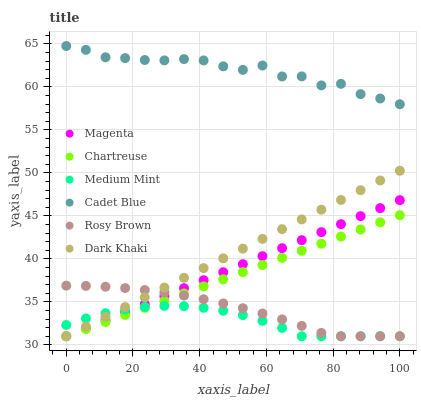Does Medium Mint have the minimum area under the curve?
Answer yes or no. Yes. Does Cadet Blue have the maximum area under the curve?
Answer yes or no. Yes. Does Rosy Brown have the minimum area under the curve?
Answer yes or no. No. Does Rosy Brown have the maximum area under the curve?
Answer yes or no. No. Is Chartreuse the smoothest?
Answer yes or no. Yes. Is Cadet Blue the roughest?
Answer yes or no. Yes. Is Rosy Brown the smoothest?
Answer yes or no. No. Is Rosy Brown the roughest?
Answer yes or no. No. Does Medium Mint have the lowest value?
Answer yes or no. Yes. Does Cadet Blue have the lowest value?
Answer yes or no. No. Does Cadet Blue have the highest value?
Answer yes or no. Yes. Does Rosy Brown have the highest value?
Answer yes or no. No. Is Rosy Brown less than Cadet Blue?
Answer yes or no. Yes. Is Cadet Blue greater than Medium Mint?
Answer yes or no. Yes. Does Medium Mint intersect Dark Khaki?
Answer yes or no. Yes. Is Medium Mint less than Dark Khaki?
Answer yes or no. No. Is Medium Mint greater than Dark Khaki?
Answer yes or no. No. Does Rosy Brown intersect Cadet Blue?
Answer yes or no. No. 